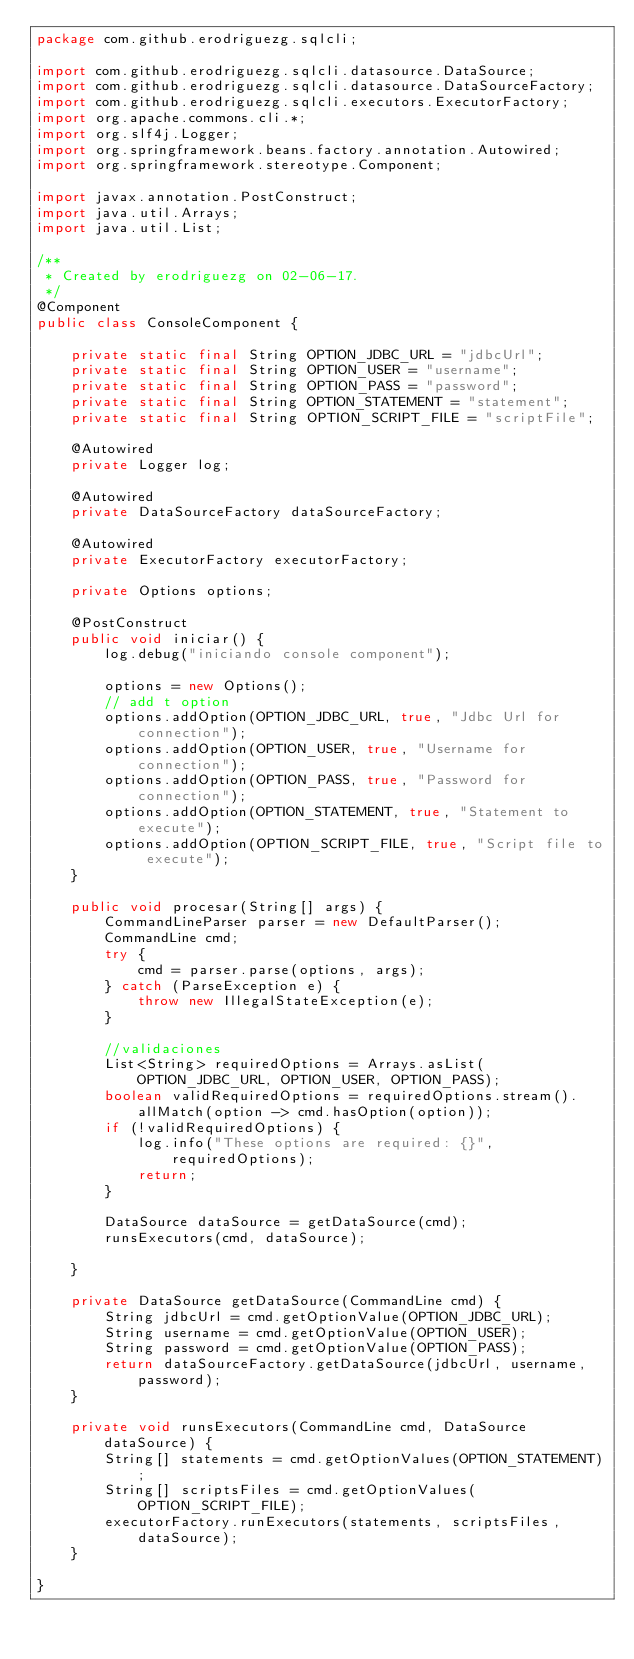Convert code to text. <code><loc_0><loc_0><loc_500><loc_500><_Java_>package com.github.erodriguezg.sqlcli;

import com.github.erodriguezg.sqlcli.datasource.DataSource;
import com.github.erodriguezg.sqlcli.datasource.DataSourceFactory;
import com.github.erodriguezg.sqlcli.executors.ExecutorFactory;
import org.apache.commons.cli.*;
import org.slf4j.Logger;
import org.springframework.beans.factory.annotation.Autowired;
import org.springframework.stereotype.Component;

import javax.annotation.PostConstruct;
import java.util.Arrays;
import java.util.List;

/**
 * Created by erodriguezg on 02-06-17.
 */
@Component
public class ConsoleComponent {

    private static final String OPTION_JDBC_URL = "jdbcUrl";
    private static final String OPTION_USER = "username";
    private static final String OPTION_PASS = "password";
    private static final String OPTION_STATEMENT = "statement";
    private static final String OPTION_SCRIPT_FILE = "scriptFile";

    @Autowired
    private Logger log;

    @Autowired
    private DataSourceFactory dataSourceFactory;

    @Autowired
    private ExecutorFactory executorFactory;

    private Options options;

    @PostConstruct
    public void iniciar() {
        log.debug("iniciando console component");

        options = new Options();
        // add t option
        options.addOption(OPTION_JDBC_URL, true, "Jdbc Url for connection");
        options.addOption(OPTION_USER, true, "Username for connection");
        options.addOption(OPTION_PASS, true, "Password for connection");
        options.addOption(OPTION_STATEMENT, true, "Statement to execute");
        options.addOption(OPTION_SCRIPT_FILE, true, "Script file to execute");
    }

    public void procesar(String[] args) {
        CommandLineParser parser = new DefaultParser();
        CommandLine cmd;
        try {
            cmd = parser.parse(options, args);
        } catch (ParseException e) {
            throw new IllegalStateException(e);
        }

        //validaciones
        List<String> requiredOptions = Arrays.asList(OPTION_JDBC_URL, OPTION_USER, OPTION_PASS);
        boolean validRequiredOptions = requiredOptions.stream().allMatch(option -> cmd.hasOption(option));
        if (!validRequiredOptions) {
            log.info("These options are required: {}", requiredOptions);
            return;
        }

        DataSource dataSource = getDataSource(cmd);
        runsExecutors(cmd, dataSource);

    }

    private DataSource getDataSource(CommandLine cmd) {
        String jdbcUrl = cmd.getOptionValue(OPTION_JDBC_URL);
        String username = cmd.getOptionValue(OPTION_USER);
        String password = cmd.getOptionValue(OPTION_PASS);
        return dataSourceFactory.getDataSource(jdbcUrl, username, password);
    }

    private void runsExecutors(CommandLine cmd, DataSource dataSource) {
        String[] statements = cmd.getOptionValues(OPTION_STATEMENT);
        String[] scriptsFiles = cmd.getOptionValues(OPTION_SCRIPT_FILE);
        executorFactory.runExecutors(statements, scriptsFiles, dataSource);
    }

}
</code> 